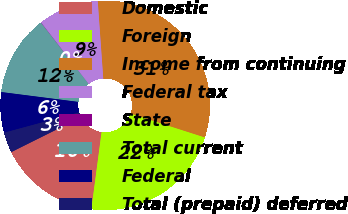<chart> <loc_0><loc_0><loc_500><loc_500><pie_chart><fcel>Domestic<fcel>Foreign<fcel>Income from continuing<fcel>Federal tax<fcel>State<fcel>Total current<fcel>Federal<fcel>Total (prepaid) deferred<nl><fcel>15.55%<fcel>22.15%<fcel>31.07%<fcel>9.35%<fcel>0.04%<fcel>12.45%<fcel>6.24%<fcel>3.14%<nl></chart> 